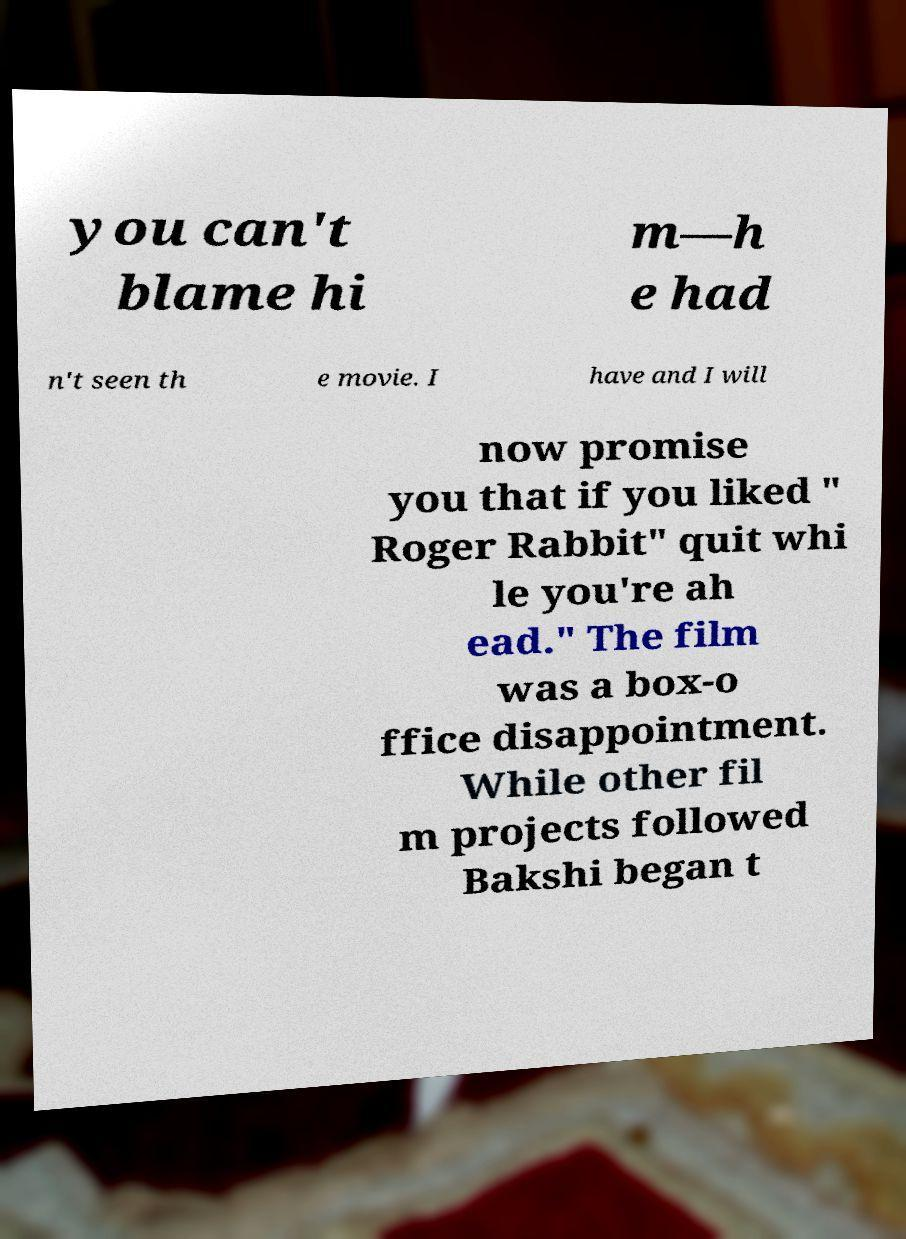Can you accurately transcribe the text from the provided image for me? you can't blame hi m—h e had n't seen th e movie. I have and I will now promise you that if you liked " Roger Rabbit" quit whi le you're ah ead." The film was a box-o ffice disappointment. While other fil m projects followed Bakshi began t 